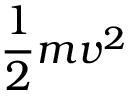Convert formula to latex. <formula><loc_0><loc_0><loc_500><loc_500>\frac { 1 } { 2 } m v ^ { 2 }</formula> 